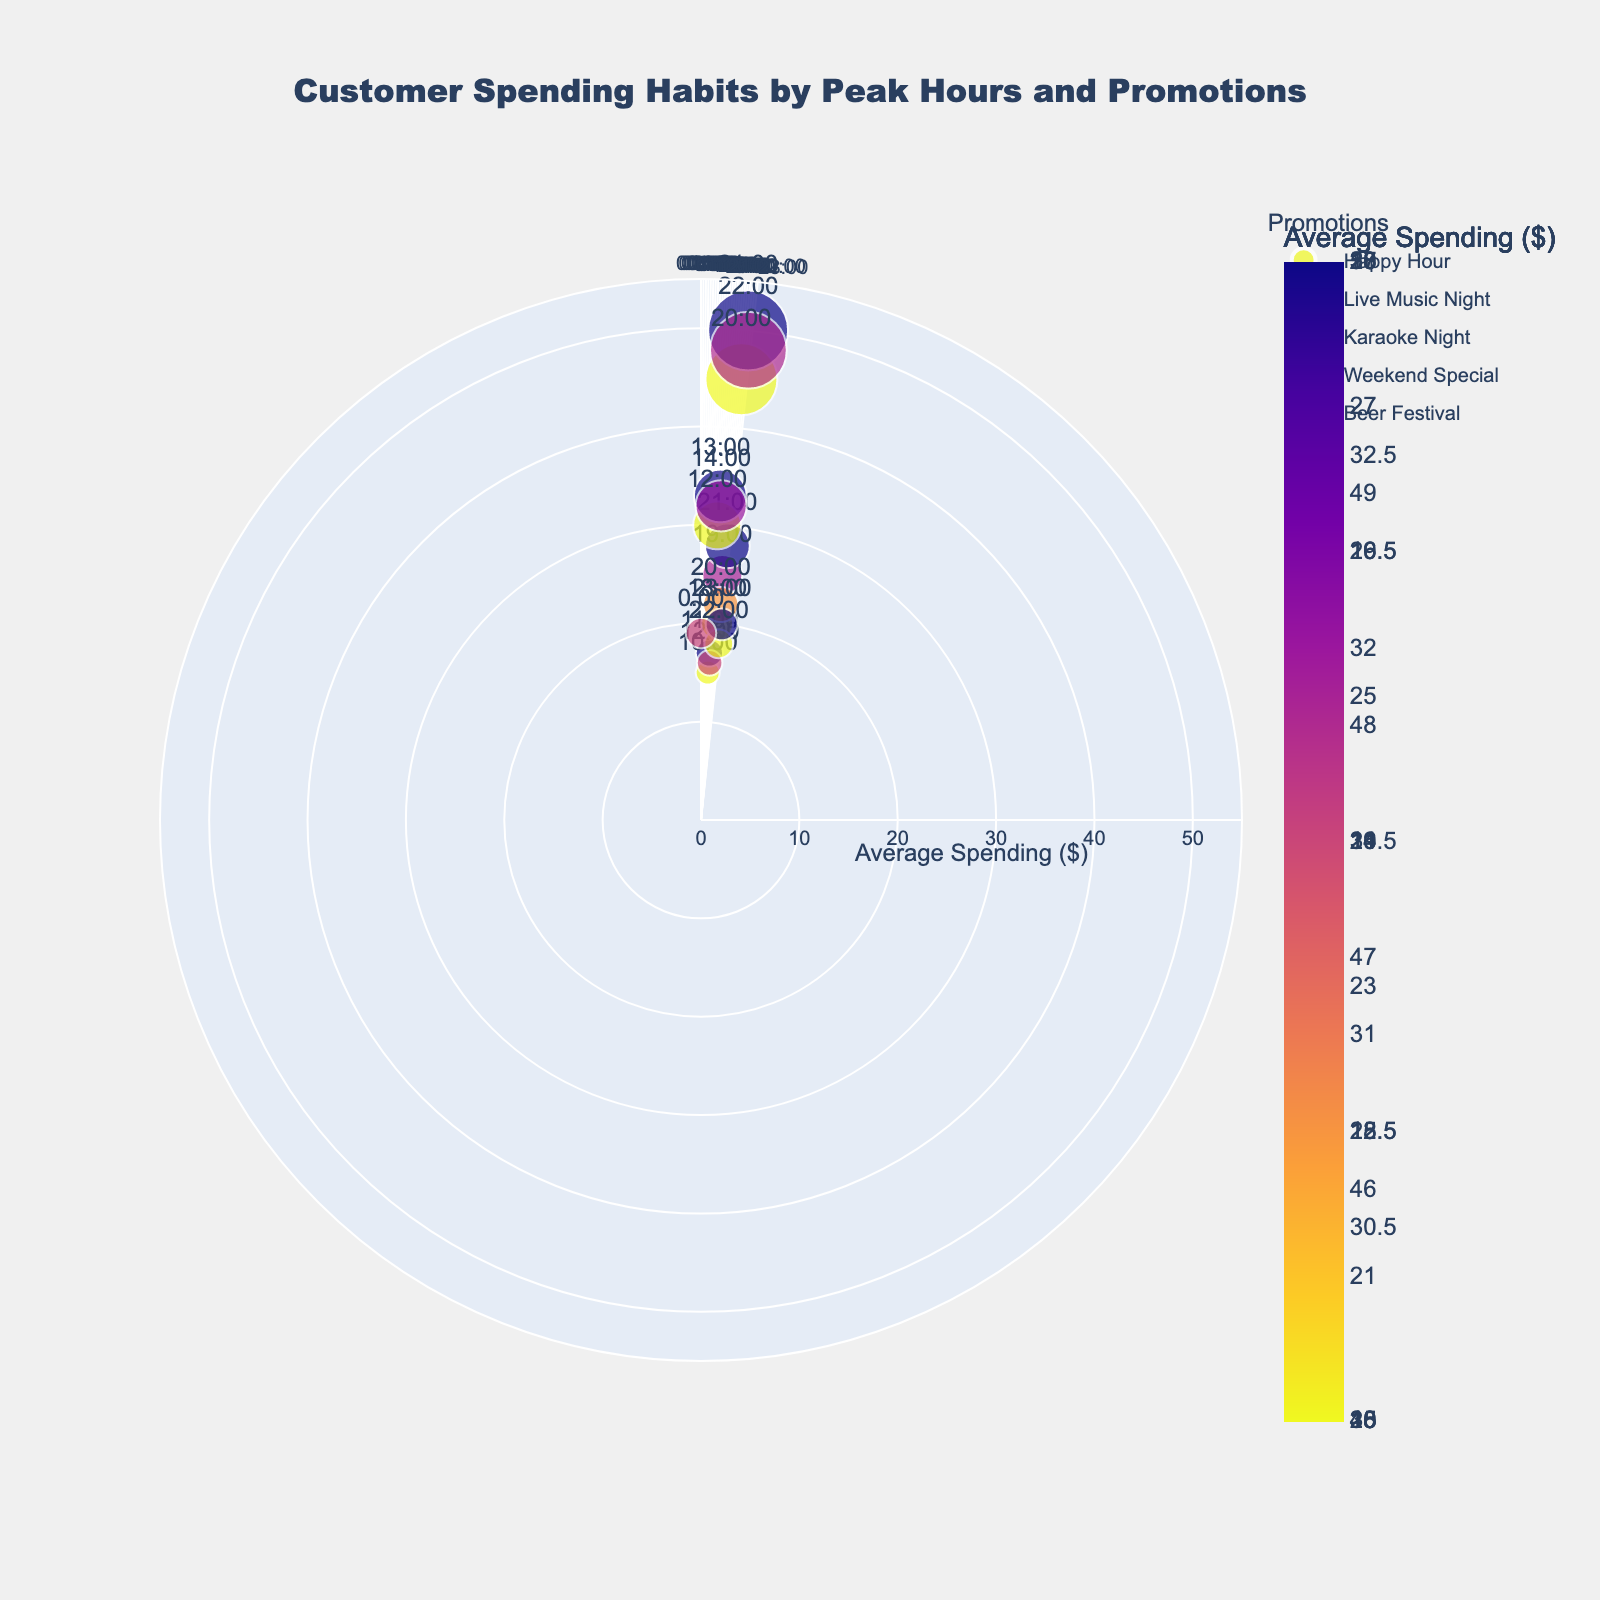What's the range of hours displayed on the plot? The plot displays hours on a circular axis in a clockwise direction, ranging from 0:00 to 23:00.
Answer: 0:00 to 23:00 What is the title of the plot? The title is displayed at the top center of the plot. It reads, "Customer Spending Habits by Peak Hours and Promotions."
Answer: Customer Spending Habits by Peak Hours and Promotions How does the spending during Live Music Night compare to Karaoke Night at 21:00? Live Music Night at 21:00 shows an average spending of $28, while Karaoke Night at 21:00 is not represented. Therefore, the comparison for 21:00 is only relevant for Live Music Night.
Answer: Live Music Night at 21:00: $28; no data for Karaoke Night at 21:00 Which promotion has the highest average spending, and at what hour does it occur? The Beer Festival at 21:00 has the highest average spending, which is $50. It can be identified by locating the largest, darkest marker on the plot.
Answer: Beer Festival at 21:00 What are the average spending values for the 12:00 hour across different promotions? At 12:00, the average spending for Happy Hour is $16, and for Weekend Special, it is $30. This is visualized by locating the points labeled 12:00 on the plot.
Answer: Happy Hour: $16; Weekend Special: $30 Which promotion tends to have more average spending, Happy Hour or Beer Festival? Comparing the markers for Happy Hour and Beer Festival, Beer Festival shows significantly higher average spending values overall. For example, Beer Festival at 21:00 has $50, while the highest for Happy Hour is $17.
Answer: Beer Festival How many distinct promotions are depicted in the plot? The legend lists the distinct promotions as Happy Hour, Live Music Night, Karaoke Night, Weekend Special, and Beer Festival, making a total of five distinct promotions.
Answer: Five At which hour does Karaoke Night have the highest average spending, and what is that value? The highest average spending for Karaoke Night occurs at 23:00, with a value of $20, as shown by the marker in the respective range.
Answer: 23:00, $20 What's the average spending overall during Live Music Night? The average spending during Live Music Night occurs at hours 18:00 ($20), 19:00 ($25), 20:00 ($22), and 21:00 ($28). Sum these values to get 20 + 25 + 22 + 28 = 95, and divide by 4.
Answer: 23.75 